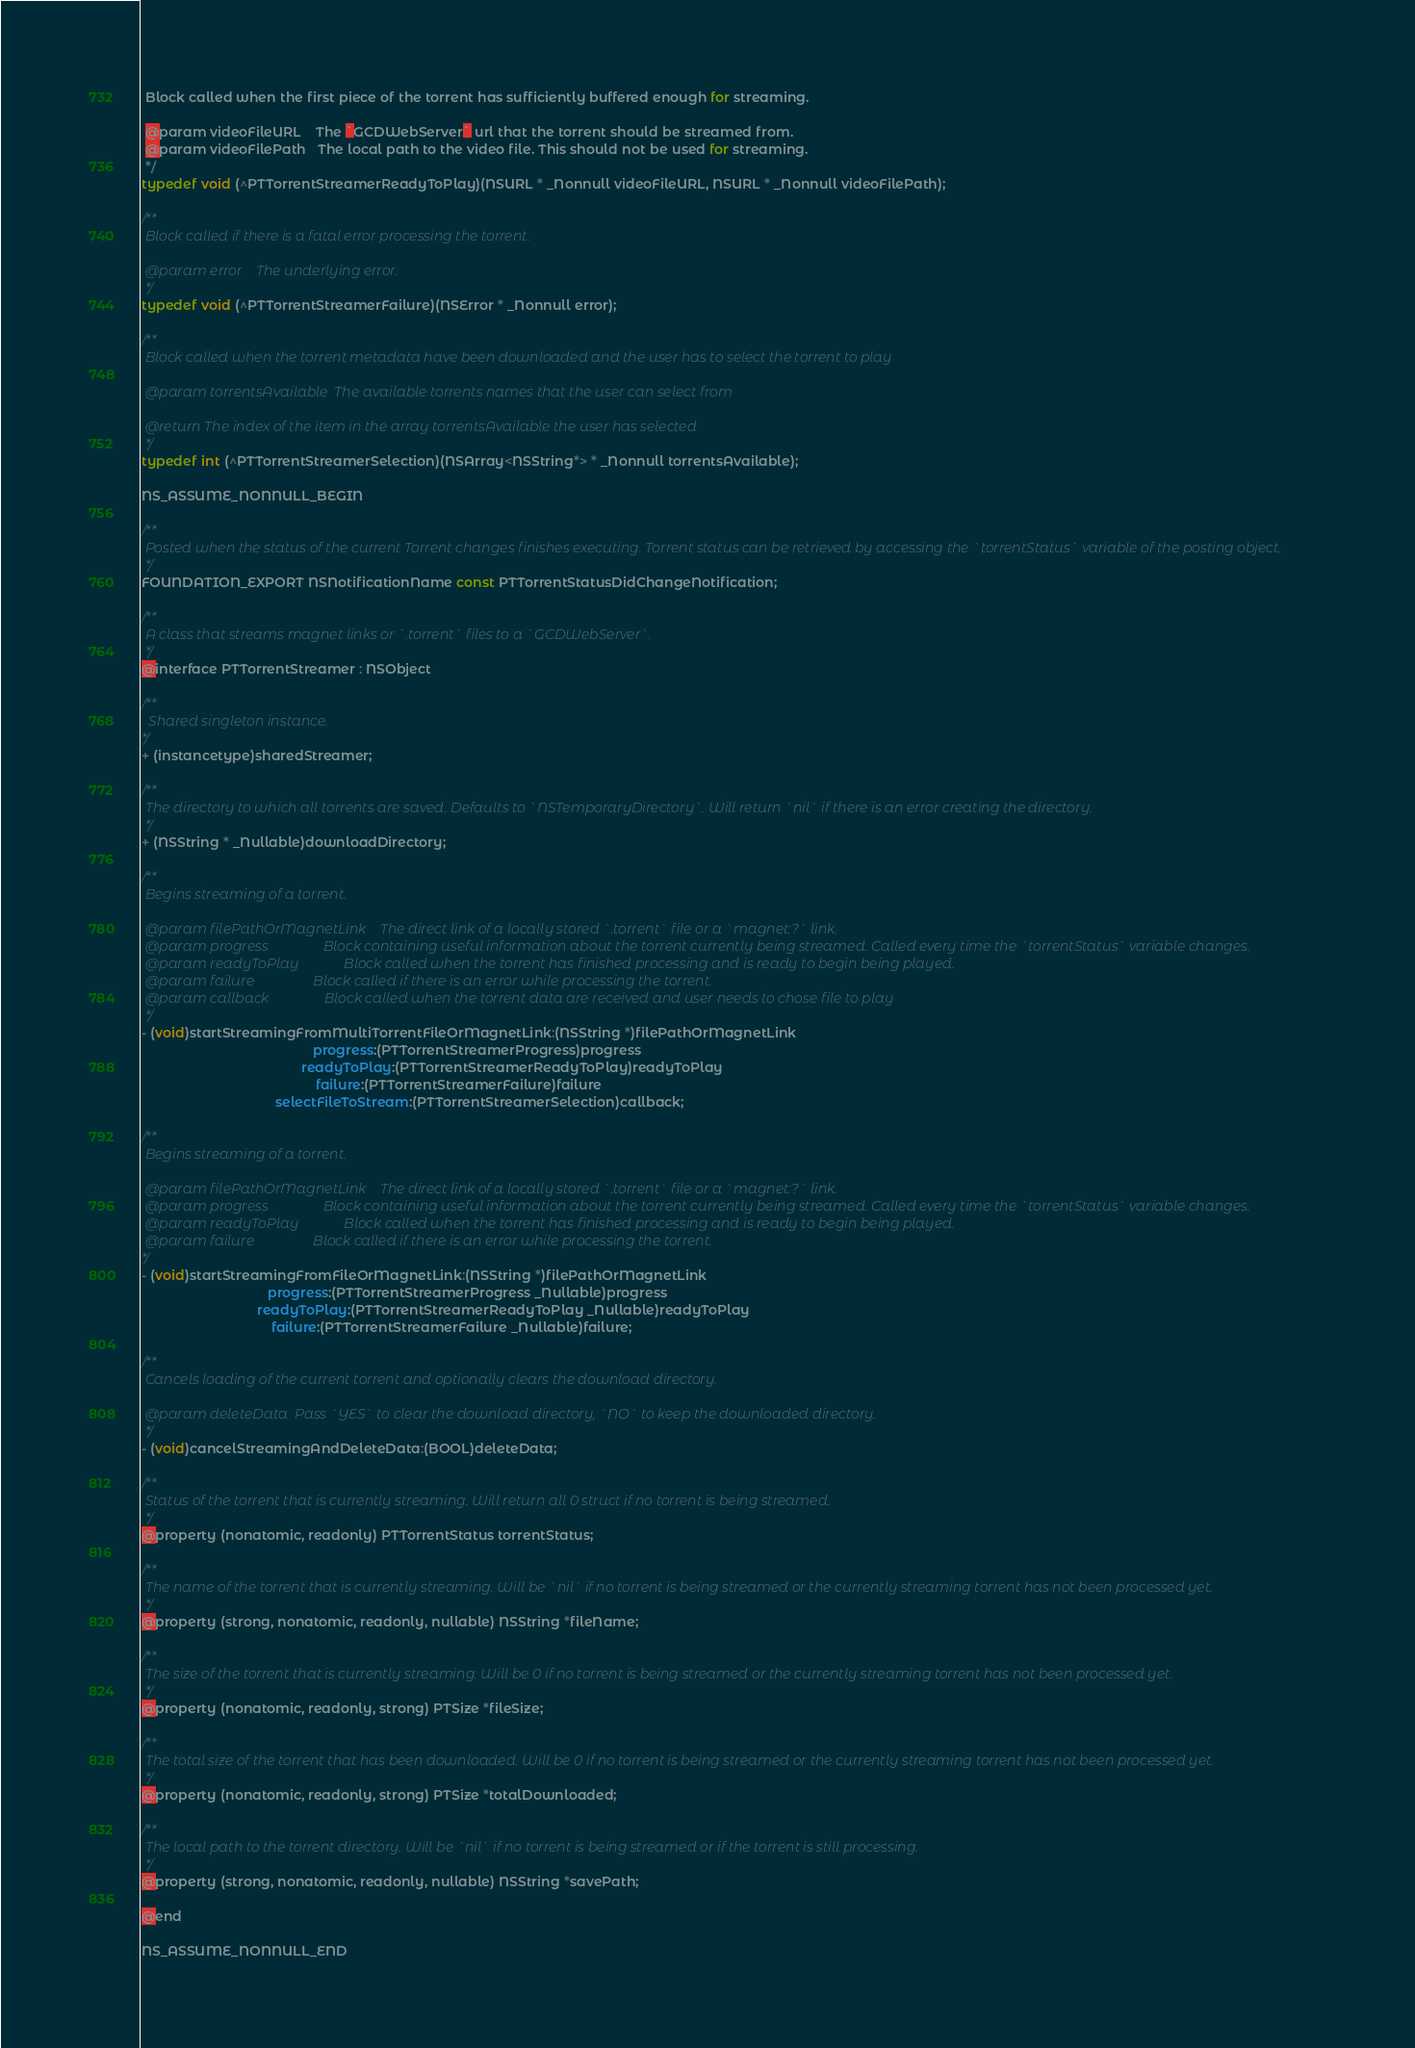<code> <loc_0><loc_0><loc_500><loc_500><_C_> Block called when the first piece of the torrent has sufficiently buffered enough for streaming.
 
 @param videoFileURL    The `GCDWebServer` url that the torrent should be streamed from.
 @param videoFilePath   The local path to the video file. This should not be used for streaming.
 */
typedef void (^PTTorrentStreamerReadyToPlay)(NSURL * _Nonnull videoFileURL, NSURL * _Nonnull videoFilePath);

/**
 Block called if there is a fatal error processing the torrent.
 
 @param error    The underlying error.
 */
typedef void (^PTTorrentStreamerFailure)(NSError * _Nonnull error);

/**
 Block called when the torrent metadata have been downloaded and the user has to select the torrent to play
 
 @param torrentsAvailable  The available torrents names that the user can select from
 
 @return The index of the item in the array torrentsAvailable the user has selected
 */
typedef int (^PTTorrentStreamerSelection)(NSArray<NSString*> * _Nonnull torrentsAvailable);

NS_ASSUME_NONNULL_BEGIN

/**
 Posted when the status of the current Torrent changes finishes executing. Torrent status can be retrieved by accessing the `torrentStatus` variable of the posting object.
 */
FOUNDATION_EXPORT NSNotificationName const PTTorrentStatusDidChangeNotification;

/**
 A class that streams magnet links or `.torrent` files to a `GCDWebServer`.
 */
@interface PTTorrentStreamer : NSObject
    
/**
  Shared singleton instance.
*/
+ (instancetype)sharedStreamer;

/**
 The directory to which all torrents are saved. Defaults to `NSTemporaryDirectory`. Will return `nil` if there is an error creating the directory.
 */
+ (NSString * _Nullable)downloadDirectory;

/**
 Begins streaming of a torrent.
 
 @param filePathOrMagnetLink    The direct link of a locally stored `.torrent` file or a `magnet:?` link.
 @param progress                Block containing useful information about the torrent currently being streamed. Called every time the `torrentStatus` variable changes.
 @param readyToPlay             Block called when the torrent has finished processing and is ready to begin being played.
 @param failure                 Block called if there is an error while processing the torrent.
 @param callback                Block called when the torrent data are received and user needs to chose file to play
 */
- (void)startStreamingFromMultiTorrentFileOrMagnetLink:(NSString *)filePathOrMagnetLink
                                              progress:(PTTorrentStreamerProgress)progress
                                           readyToPlay:(PTTorrentStreamerReadyToPlay)readyToPlay
                                               failure:(PTTorrentStreamerFailure)failure
                                    selectFileToStream:(PTTorrentStreamerSelection)callback;

/**
 Begins streaming of a torrent.
 
 @param filePathOrMagnetLink    The direct link of a locally stored `.torrent` file or a `magnet:?` link.
 @param progress                Block containing useful information about the torrent currently being streamed. Called every time the `torrentStatus` variable changes.
 @param readyToPlay             Block called when the torrent has finished processing and is ready to begin being played.
 @param failure                 Block called if there is an error while processing the torrent.
*/
- (void)startStreamingFromFileOrMagnetLink:(NSString *)filePathOrMagnetLink
                                  progress:(PTTorrentStreamerProgress _Nullable)progress
                               readyToPlay:(PTTorrentStreamerReadyToPlay _Nullable)readyToPlay
                                   failure:(PTTorrentStreamerFailure _Nullable)failure;

/**
 Cancels loading of the current torrent and optionally clears the download directory.
 
 @param deleteData  Pass `YES` to clear the download directory, `NO` to keep the downloaded directory.
 */
- (void)cancelStreamingAndDeleteData:(BOOL)deleteData;
    
/**
 Status of the torrent that is currently streaming. Will return all 0 struct if no torrent is being streamed.
 */
@property (nonatomic, readonly) PTTorrentStatus torrentStatus;

/**
 The name of the torrent that is currently streaming. Will be `nil` if no torrent is being streamed or the currently streaming torrent has not been processed yet.
 */
@property (strong, nonatomic, readonly, nullable) NSString *fileName;

/**
 The size of the torrent that is currently streaming. Will be 0 if no torrent is being streamed or the currently streaming torrent has not been processed yet.
 */
@property (nonatomic, readonly, strong) PTSize *fileSize;

/**
 The total size of the torrent that has been downloaded. Will be 0 if no torrent is being streamed or the currently streaming torrent has not been processed yet.
 */
@property (nonatomic, readonly, strong) PTSize *totalDownloaded;

/**
 The local path to the torrent directory. Will be `nil` if no torrent is being streamed or if the torrent is still processing.
 */
@property (strong, nonatomic, readonly, nullable) NSString *savePath;

@end

NS_ASSUME_NONNULL_END
</code> 